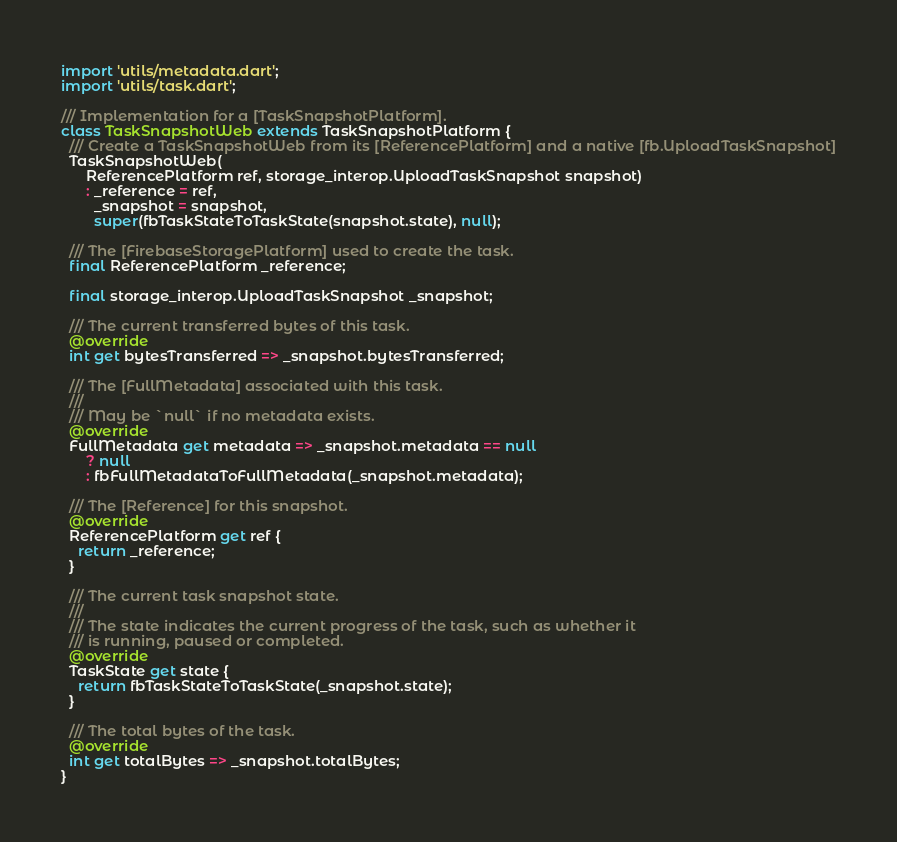Convert code to text. <code><loc_0><loc_0><loc_500><loc_500><_Dart_>import 'utils/metadata.dart';
import 'utils/task.dart';

/// Implementation for a [TaskSnapshotPlatform].
class TaskSnapshotWeb extends TaskSnapshotPlatform {
  /// Create a TaskSnapshotWeb from its [ReferencePlatform] and a native [fb.UploadTaskSnapshot]
  TaskSnapshotWeb(
      ReferencePlatform ref, storage_interop.UploadTaskSnapshot snapshot)
      : _reference = ref,
        _snapshot = snapshot,
        super(fbTaskStateToTaskState(snapshot.state), null);

  /// The [FirebaseStoragePlatform] used to create the task.
  final ReferencePlatform _reference;

  final storage_interop.UploadTaskSnapshot _snapshot;

  /// The current transferred bytes of this task.
  @override
  int get bytesTransferred => _snapshot.bytesTransferred;

  /// The [FullMetadata] associated with this task.
  ///
  /// May be `null` if no metadata exists.
  @override
  FullMetadata get metadata => _snapshot.metadata == null
      ? null
      : fbFullMetadataToFullMetadata(_snapshot.metadata);

  /// The [Reference] for this snapshot.
  @override
  ReferencePlatform get ref {
    return _reference;
  }

  /// The current task snapshot state.
  ///
  /// The state indicates the current progress of the task, such as whether it
  /// is running, paused or completed.
  @override
  TaskState get state {
    return fbTaskStateToTaskState(_snapshot.state);
  }

  /// The total bytes of the task.
  @override
  int get totalBytes => _snapshot.totalBytes;
}
</code> 